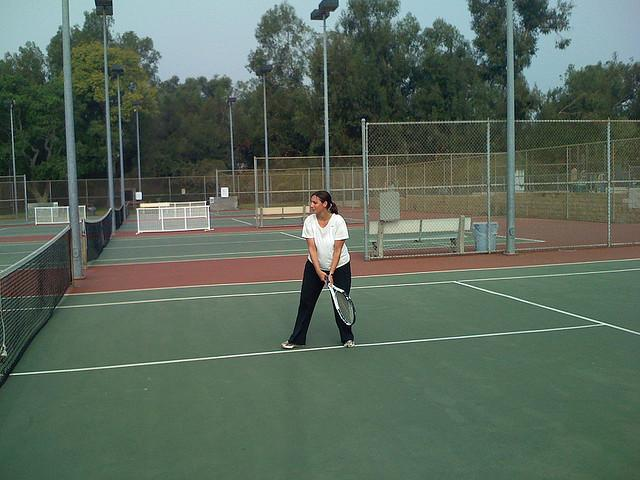What are the tall silver poles used for? lights 